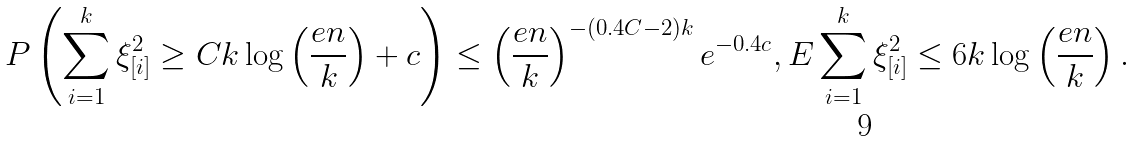Convert formula to latex. <formula><loc_0><loc_0><loc_500><loc_500>P \left ( \sum _ { i = 1 } ^ { k } \xi _ { [ i ] } ^ { 2 } \geq C k \log \left ( \frac { e n } { k } \right ) + c \right ) \leq \left ( \frac { e n } { k } \right ) ^ { - ( 0 . 4 C - 2 ) k } e ^ { - 0 . 4 c } , E \sum _ { i = 1 } ^ { k } \xi _ { [ i ] } ^ { 2 } \leq 6 k \log \left ( \frac { e n } { k } \right ) .</formula> 